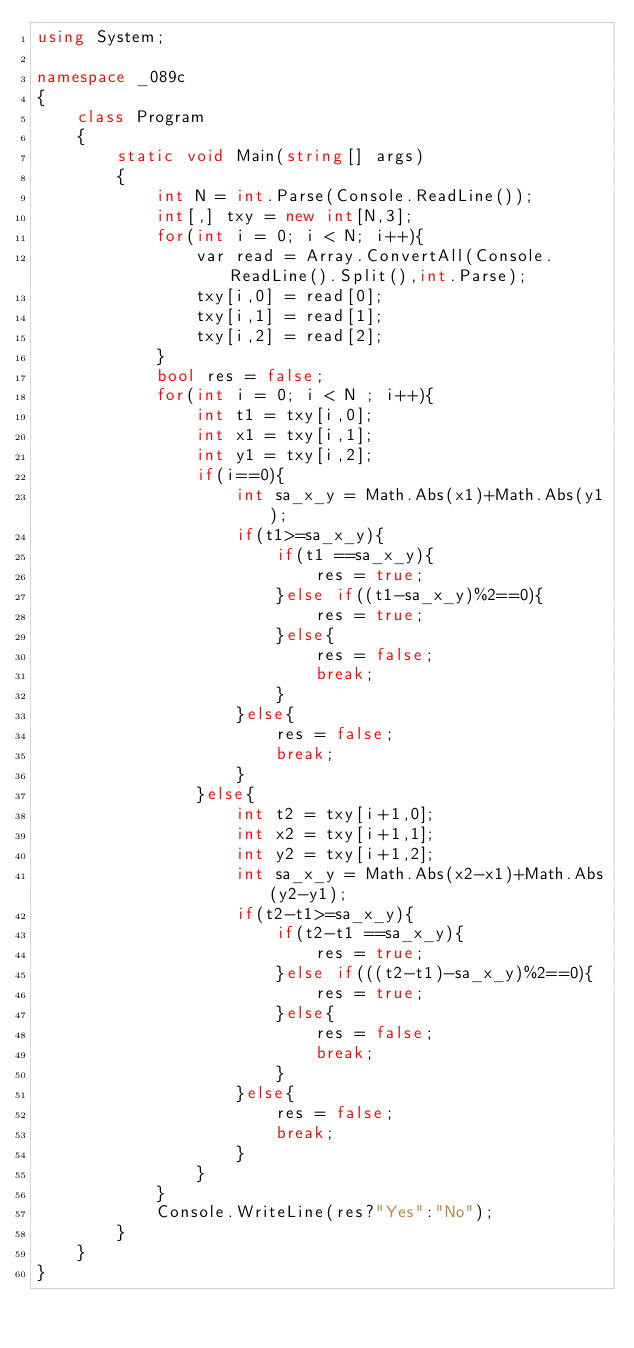<code> <loc_0><loc_0><loc_500><loc_500><_C#_>using System;

namespace _089c
{
    class Program
    {
        static void Main(string[] args)
        {
            int N = int.Parse(Console.ReadLine());
            int[,] txy = new int[N,3];
            for(int i = 0; i < N; i++){
                var read = Array.ConvertAll(Console.ReadLine().Split(),int.Parse);
                txy[i,0] = read[0];
                txy[i,1] = read[1];
                txy[i,2] = read[2];
            } 
            bool res = false;
            for(int i = 0; i < N ; i++){
                int t1 = txy[i,0];
                int x1 = txy[i,1];
                int y1 = txy[i,2];
                if(i==0){
                    int sa_x_y = Math.Abs(x1)+Math.Abs(y1);
                    if(t1>=sa_x_y){
                        if(t1 ==sa_x_y){
                            res = true;
                        }else if((t1-sa_x_y)%2==0){
                            res = true;
                        }else{
                            res = false;
                            break;
                        }
                    }else{
                        res = false;
                        break;
                    }  
                }else{
                    int t2 = txy[i+1,0];
                    int x2 = txy[i+1,1];
                    int y2 = txy[i+1,2];
                    int sa_x_y = Math.Abs(x2-x1)+Math.Abs(y2-y1);
                    if(t2-t1>=sa_x_y){
                        if(t2-t1 ==sa_x_y){
                            res = true;
                        }else if(((t2-t1)-sa_x_y)%2==0){
                            res = true;
                        }else{
                            res = false;
                            break;
                        }
                    }else{
                        res = false;
                        break;
                    }
                }
            }
            Console.WriteLine(res?"Yes":"No");
        }
    }
}</code> 